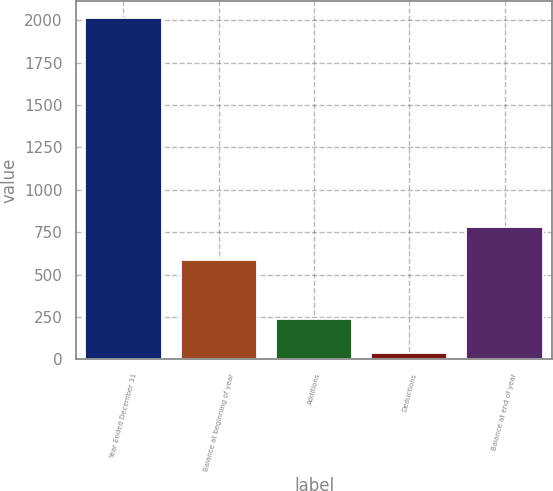Convert chart to OTSL. <chart><loc_0><loc_0><loc_500><loc_500><bar_chart><fcel>Year Ended December 31<fcel>Balance at beginning of year<fcel>Additions<fcel>Deductions<fcel>Balance at end of year<nl><fcel>2014<fcel>586<fcel>238.3<fcel>41<fcel>783.3<nl></chart> 